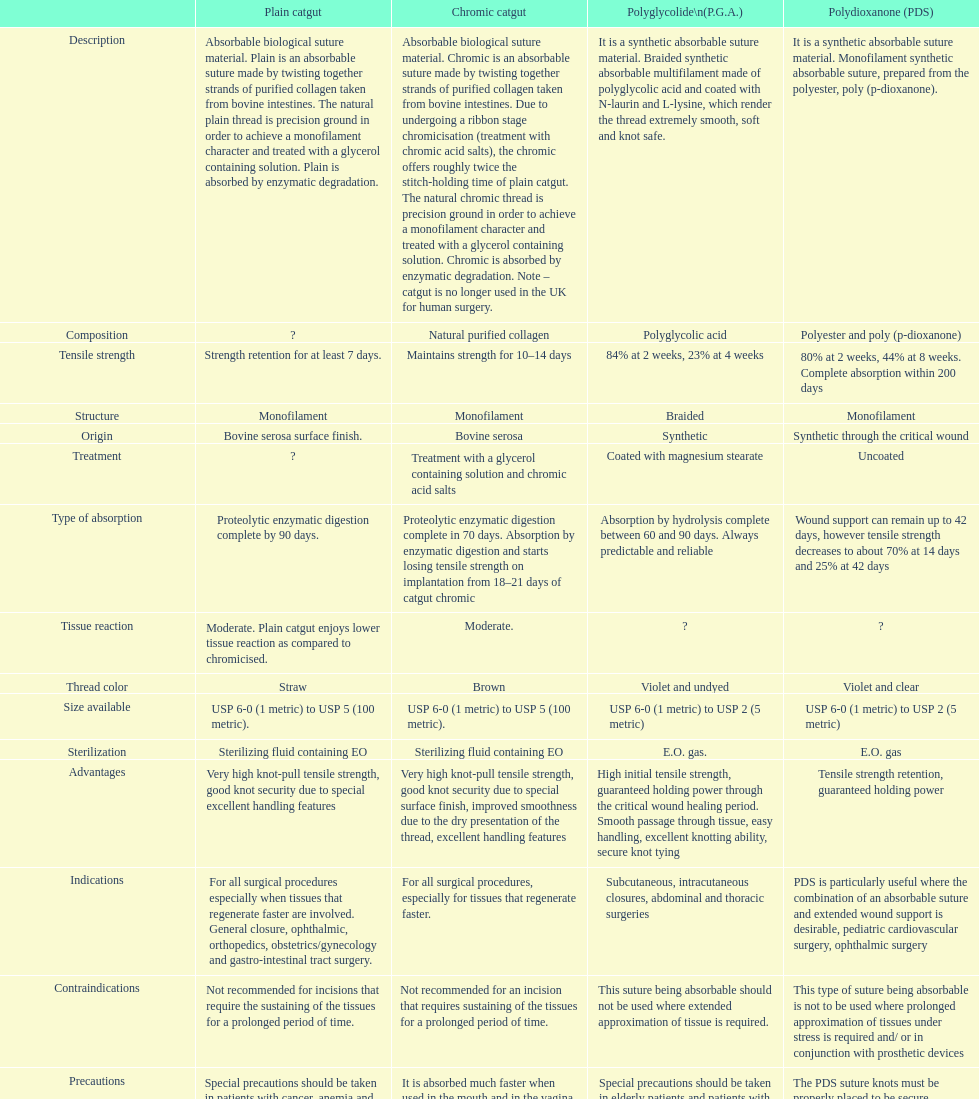Apart from monofilament, what is another structure? Braided. 